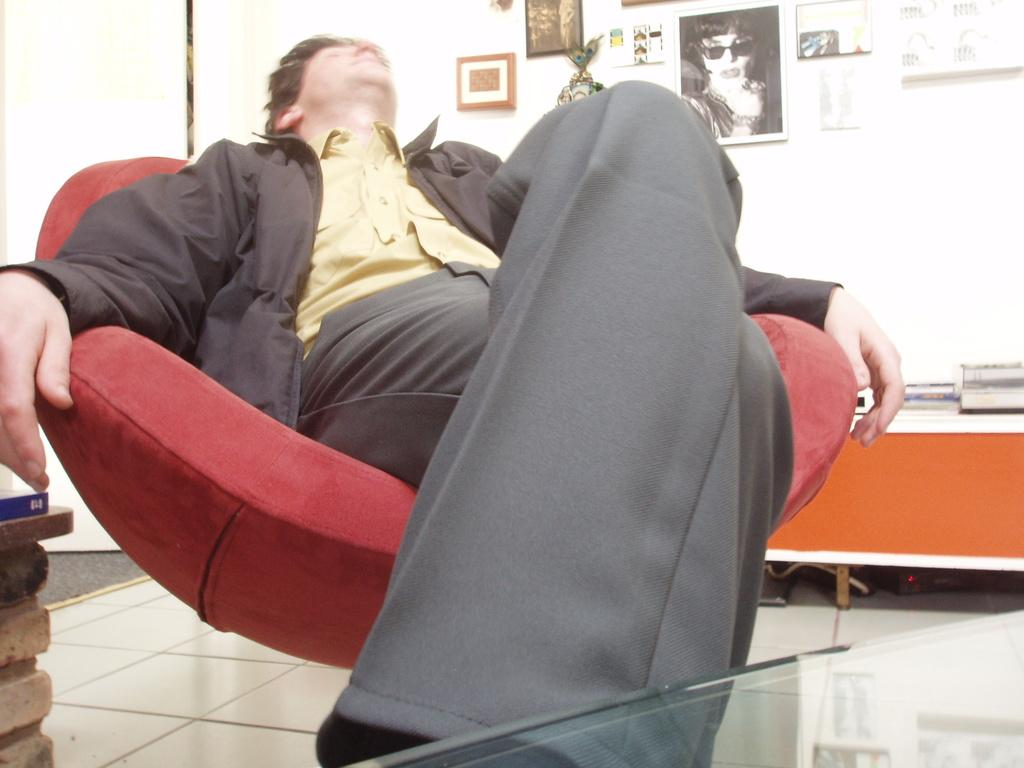What are the men in the image doing? The men in the image are sitting on chairs. What can be seen on the wall in the image? There are frames on the wall in the image. What piece of furniture is present in the image besides the chairs? There is a table in the image. What items are on the table in the image? There are books on the table in the image. What color is the sweater worn by the father in the image? There is no sweater or father present in the image. How many houses are visible in the image? There are no houses visible in the image. 